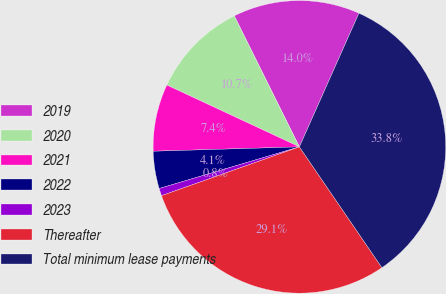<chart> <loc_0><loc_0><loc_500><loc_500><pie_chart><fcel>2019<fcel>2020<fcel>2021<fcel>2022<fcel>2023<fcel>Thereafter<fcel>Total minimum lease payments<nl><fcel>14.01%<fcel>10.71%<fcel>7.42%<fcel>4.12%<fcel>0.82%<fcel>29.12%<fcel>33.79%<nl></chart> 